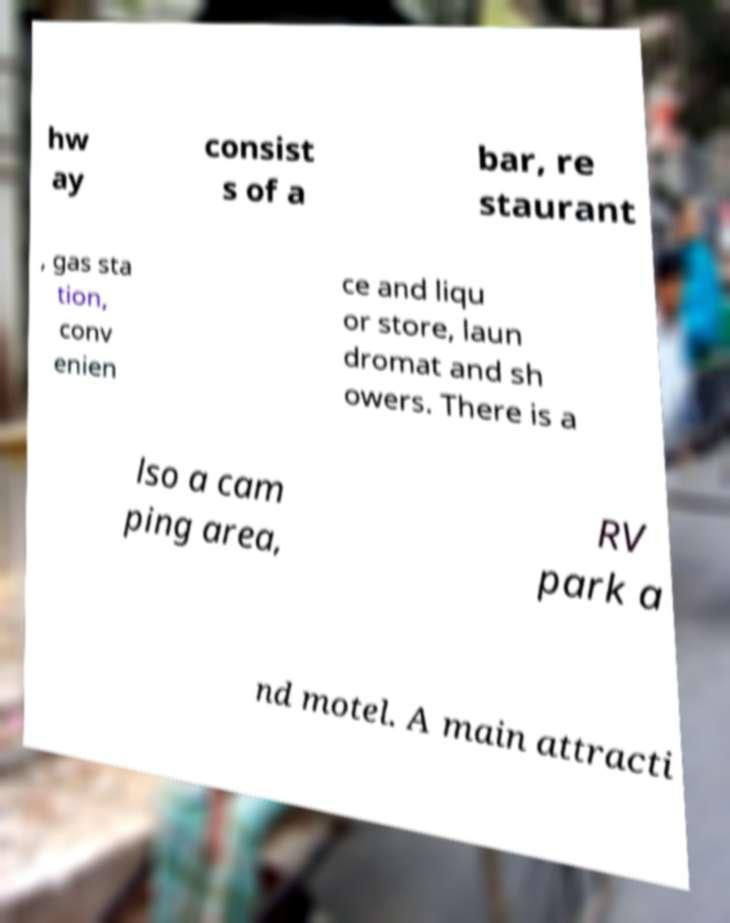What messages or text are displayed in this image? I need them in a readable, typed format. hw ay consist s of a bar, re staurant , gas sta tion, conv enien ce and liqu or store, laun dromat and sh owers. There is a lso a cam ping area, RV park a nd motel. A main attracti 